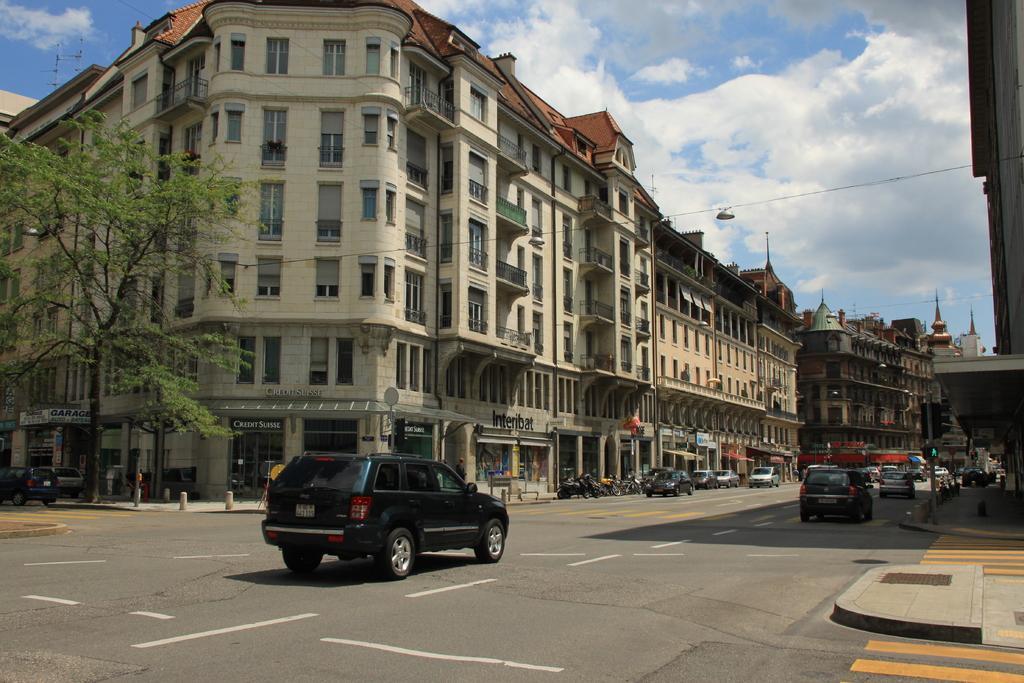Describe this image in one or two sentences. In this image there is a road on which there are so many cars. Behind the road there are buildings on either side of the road. On the footpath there is a tree on the left side. At the top there is sky. 